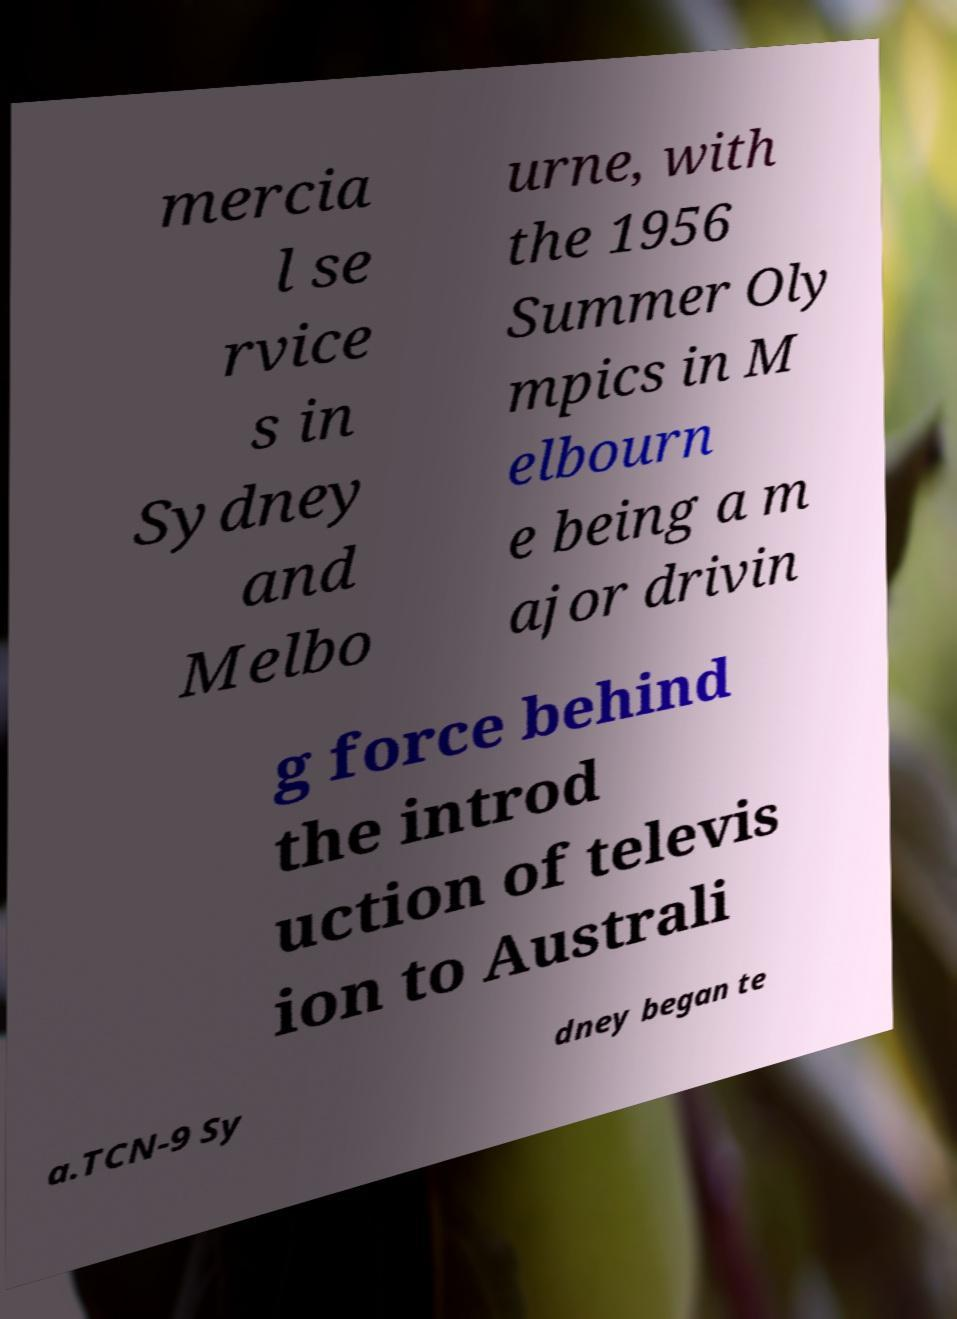Can you accurately transcribe the text from the provided image for me? mercia l se rvice s in Sydney and Melbo urne, with the 1956 Summer Oly mpics in M elbourn e being a m ajor drivin g force behind the introd uction of televis ion to Australi a.TCN-9 Sy dney began te 